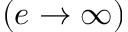Convert formula to latex. <formula><loc_0><loc_0><loc_500><loc_500>( e \to \infty )</formula> 